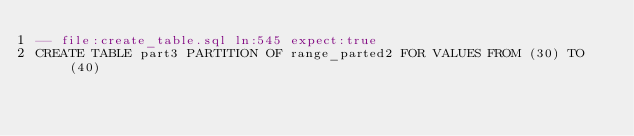Convert code to text. <code><loc_0><loc_0><loc_500><loc_500><_SQL_>-- file:create_table.sql ln:545 expect:true
CREATE TABLE part3 PARTITION OF range_parted2 FOR VALUES FROM (30) TO (40)
</code> 